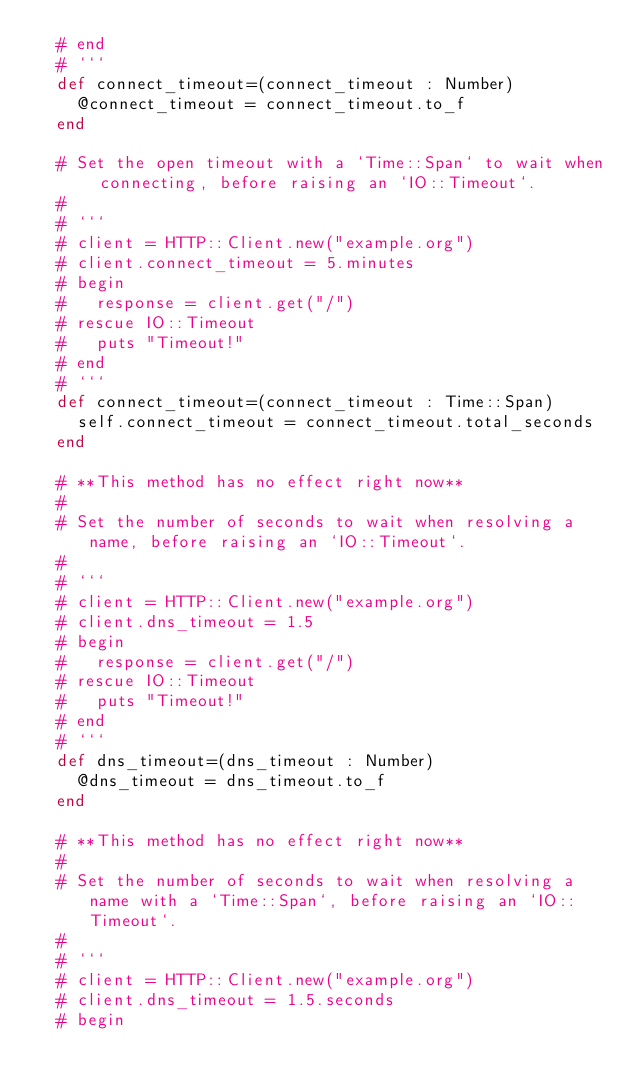Convert code to text. <code><loc_0><loc_0><loc_500><loc_500><_Crystal_>  # end
  # ```
  def connect_timeout=(connect_timeout : Number)
    @connect_timeout = connect_timeout.to_f
  end

  # Set the open timeout with a `Time::Span` to wait when connecting, before raising an `IO::Timeout`.
  #
  # ```
  # client = HTTP::Client.new("example.org")
  # client.connect_timeout = 5.minutes
  # begin
  #   response = client.get("/")
  # rescue IO::Timeout
  #   puts "Timeout!"
  # end
  # ```
  def connect_timeout=(connect_timeout : Time::Span)
    self.connect_timeout = connect_timeout.total_seconds
  end

  # **This method has no effect right now**
  #
  # Set the number of seconds to wait when resolving a name, before raising an `IO::Timeout`.
  #
  # ```
  # client = HTTP::Client.new("example.org")
  # client.dns_timeout = 1.5
  # begin
  #   response = client.get("/")
  # rescue IO::Timeout
  #   puts "Timeout!"
  # end
  # ```
  def dns_timeout=(dns_timeout : Number)
    @dns_timeout = dns_timeout.to_f
  end

  # **This method has no effect right now**
  #
  # Set the number of seconds to wait when resolving a name with a `Time::Span`, before raising an `IO::Timeout`.
  #
  # ```
  # client = HTTP::Client.new("example.org")
  # client.dns_timeout = 1.5.seconds
  # begin</code> 